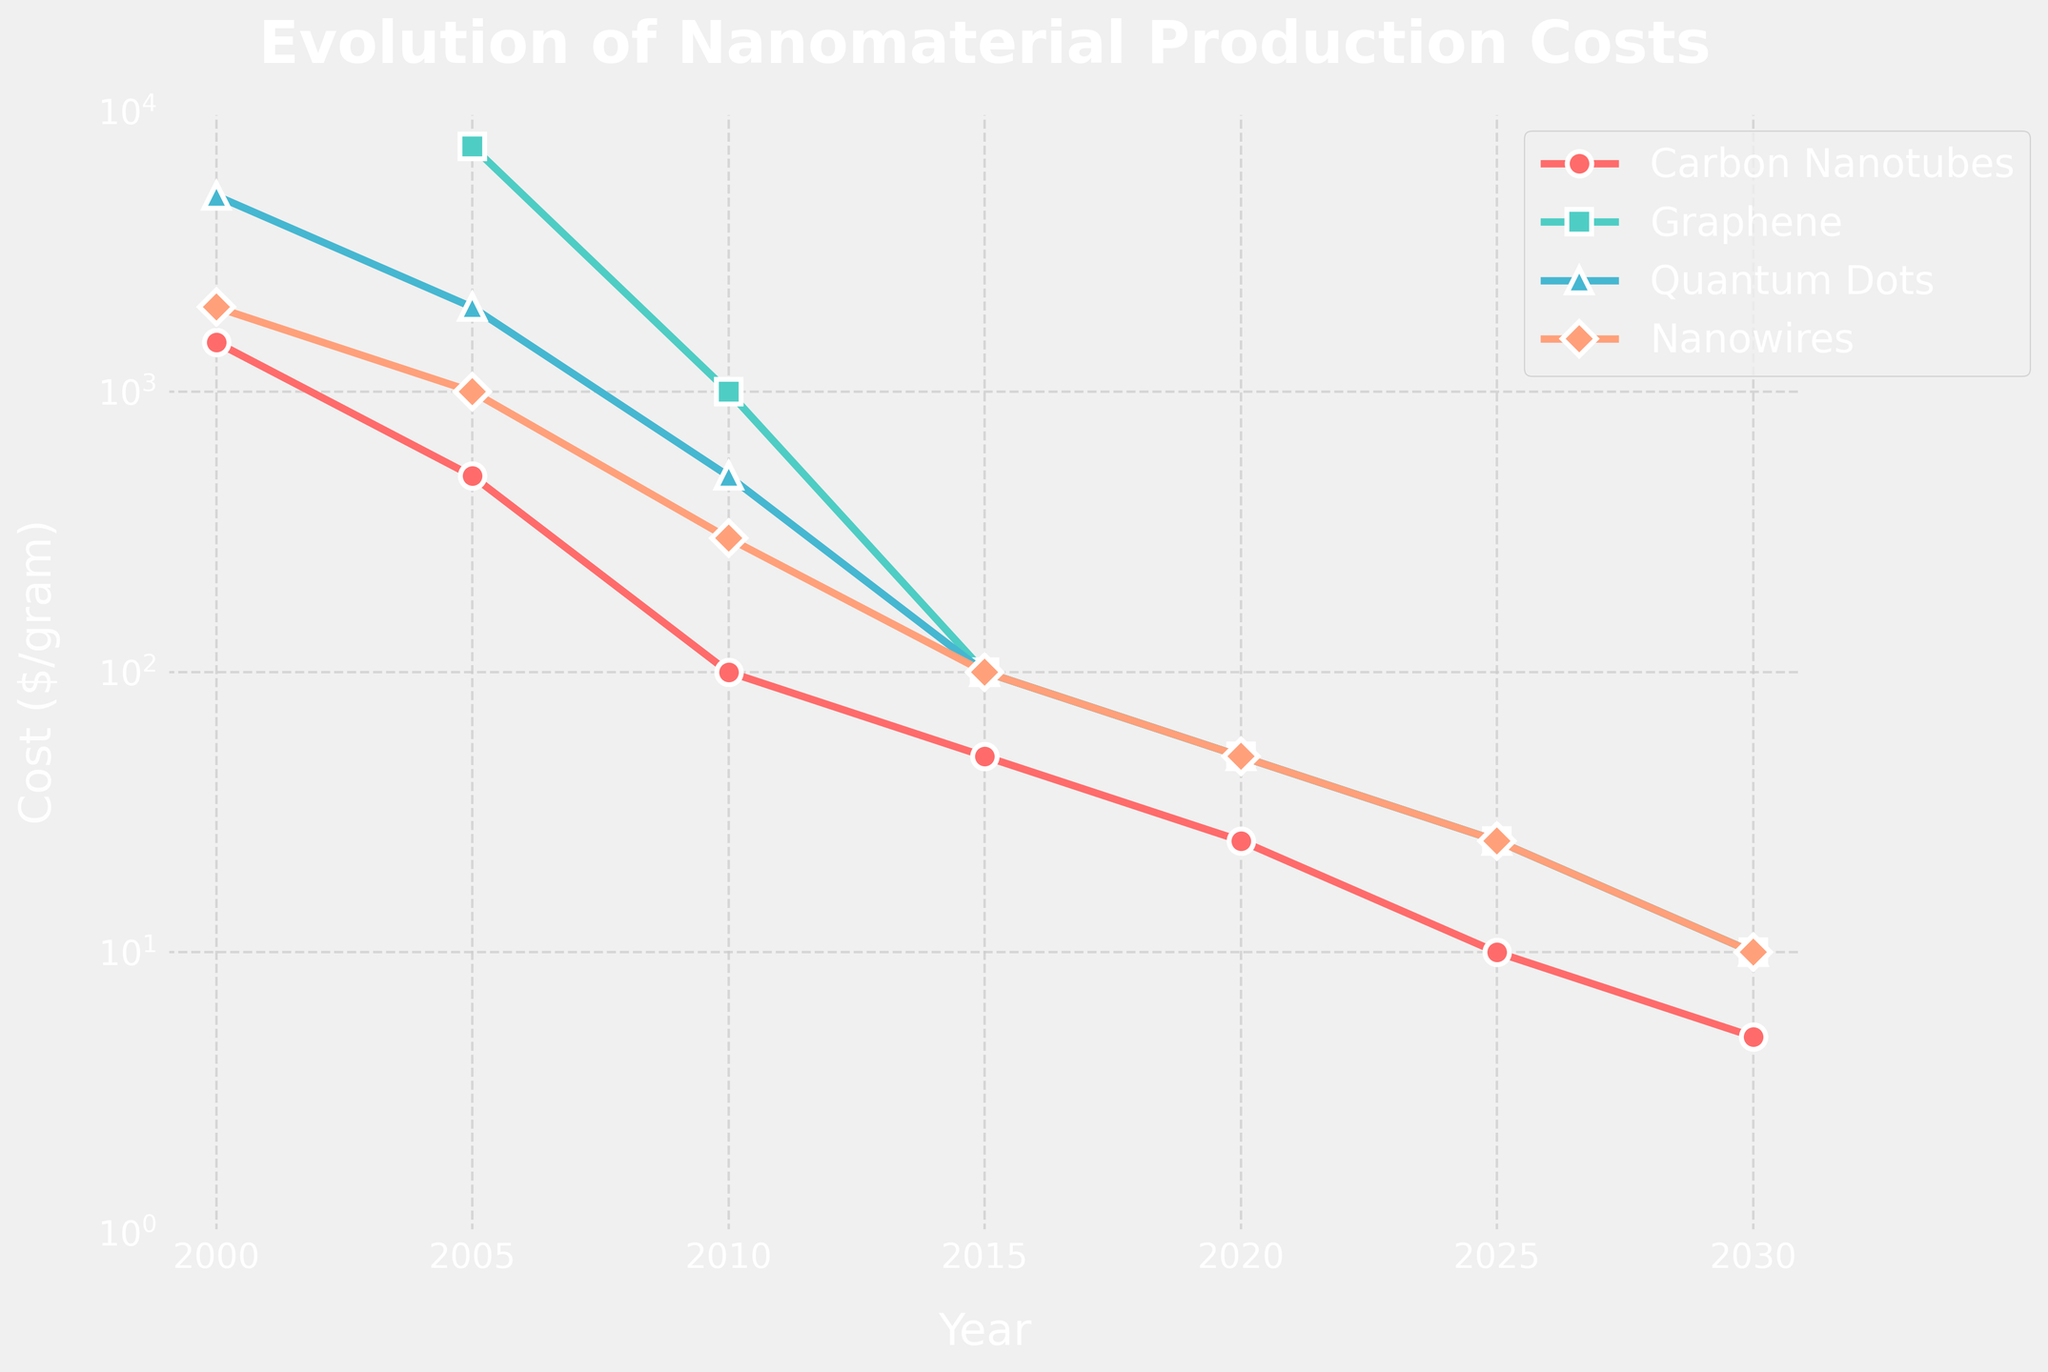What's the overall trend in the production costs of nanomaterials over the given period? The plot shows that production costs for all four nanomaterials (Carbon Nanotubes, Graphene, Quantum Dots, and Nanowires) exhibit a significant decrease from 2000 to 2030.
Answer: Decreasing How does the cost of Carbon Nanotubes in 2030 compare with the cost of Graphene in 2005? In the plot, the cost of Carbon Nanotubes in 2030 is $5/gram, while the cost of Graphene in 2005 is $7500/gram.
Answer: Lower Which material had the highest production cost in 2000? According to the chart, Quantum Dots had a production cost of $5000/gram in 2000, which is the highest among the listed materials.
Answer: Quantum Dots By how much did the cost of Nanowires drop from 2000 to 2020? The cost of Nanowires in 2000 was $2000/gram, and in 2020 it was $50/gram. The drop is calculated as $2000 - $50 = $1950/gram.
Answer: $1950/gram At which year did Graphene's production cost fall below $1000 per gram? The cost of Graphene fell below $1000 per gram between 2005 and 2010. By 2010, the production cost of Graphene was $1000/gram.
Answer: 2010 How many years did it take for Quantum Dots' production costs to decrease by 99% from their initial value? The initial cost in 2000 was $5000/gram, and 99% reduction means a final cost of $50/gram. This reduction occurred between 2000 and 2020, taking 20 years.
Answer: 20 years What was the average cost of Carbon Nanotubes from 2000 to 2030? The costs of Carbon Nanotubes from 2000 to 2030 are $1500, $500, $100, $50, $25, $10, and $5. The average is calculated as (1500 + 500 + 100 + 50 + 25 + 10 + 5) / 7 = 3190/7 ≈ 455.71
Answer: $455.71 Which year saw the most significant cost reduction for Nanowires? The cost of Nanowires dropped significantly between 2000 and 2005 from $2000 to $1000, which is the largest reduction of $1000 in the given data.
Answer: 2000-2005 In 2030, are the production costs of all materials equal? In the plot, the costs of Carbon Nanotubes, Graphene, Quantum Dots, and Nanowires in 2030 are all $10/gram.
Answer: Yes 